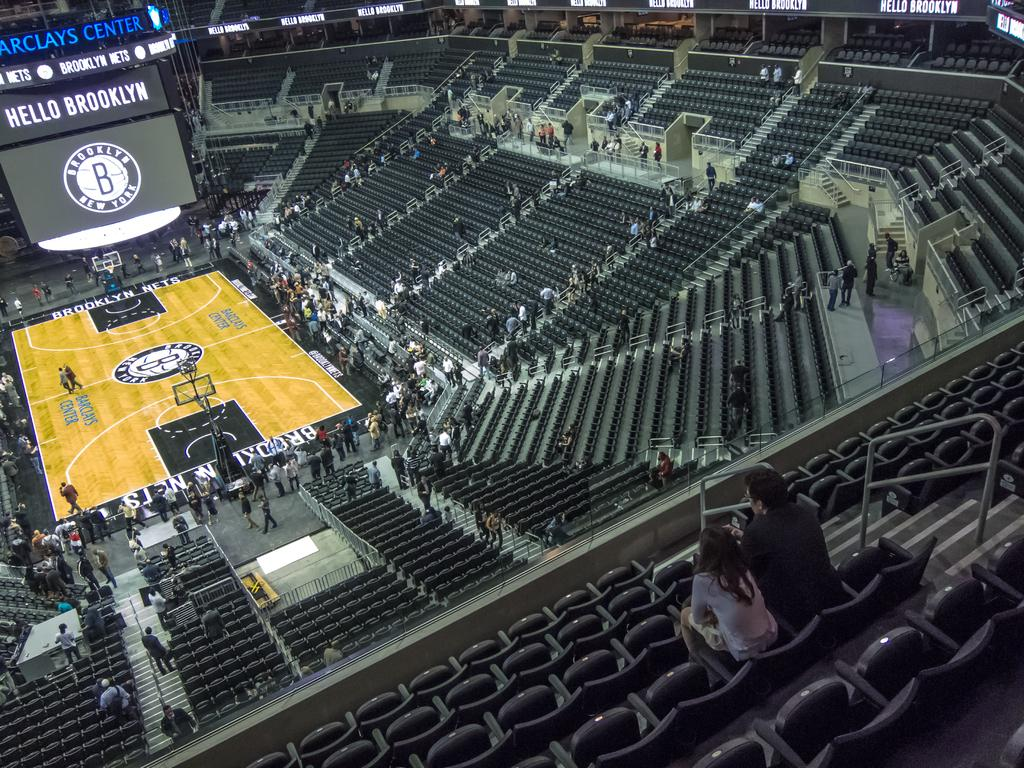<image>
Render a clear and concise summary of the photo. The Barclays center is nearly empty before a game 